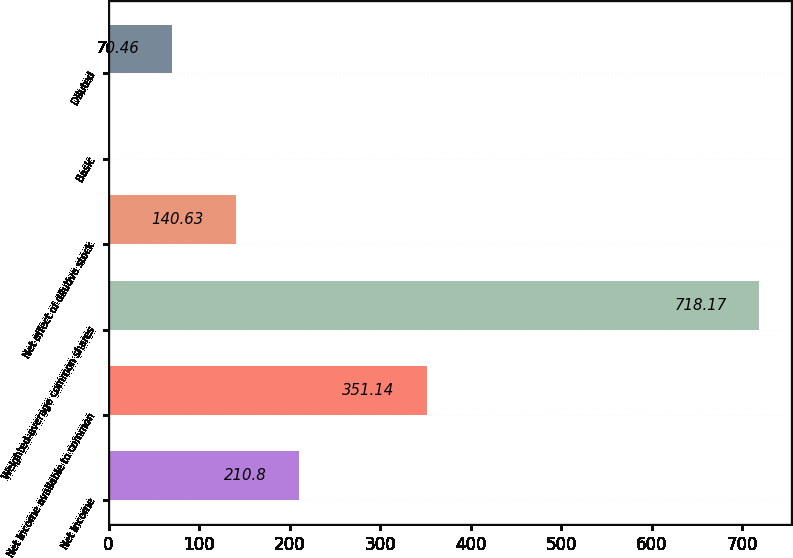Convert chart to OTSL. <chart><loc_0><loc_0><loc_500><loc_500><bar_chart><fcel>Net income<fcel>Net income available to common<fcel>Weighted-average common shares<fcel>Net effect of dilutive stock<fcel>Basic<fcel>Diluted<nl><fcel>210.8<fcel>351.14<fcel>718.17<fcel>140.63<fcel>0.29<fcel>70.46<nl></chart> 